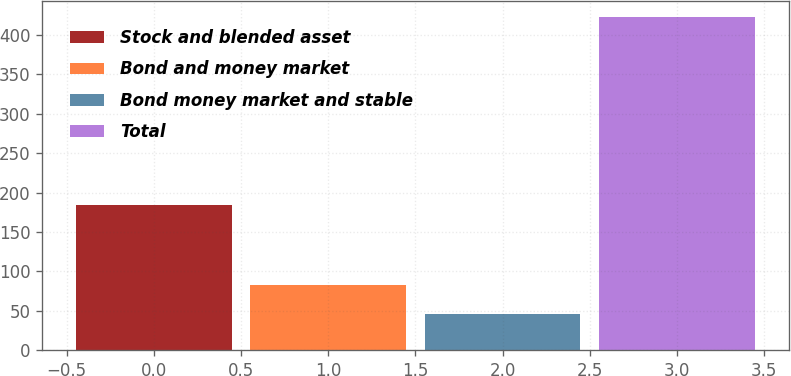Convert chart. <chart><loc_0><loc_0><loc_500><loc_500><bar_chart><fcel>Stock and blended asset<fcel>Bond and money market<fcel>Bond money market and stable<fcel>Total<nl><fcel>184.7<fcel>83.3<fcel>45.6<fcel>422.6<nl></chart> 